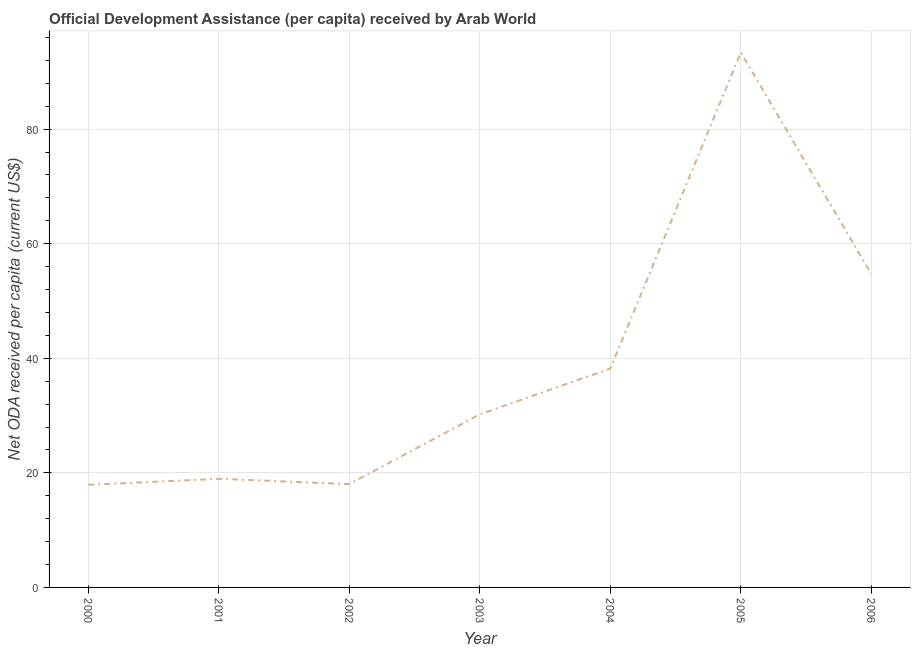What is the net oda received per capita in 2001?
Make the answer very short. 18.96. Across all years, what is the maximum net oda received per capita?
Your answer should be very brief. 93.38. Across all years, what is the minimum net oda received per capita?
Offer a very short reply. 17.91. In which year was the net oda received per capita minimum?
Offer a very short reply. 2000. What is the sum of the net oda received per capita?
Provide a succinct answer. 271.38. What is the difference between the net oda received per capita in 2000 and 2001?
Provide a succinct answer. -1.05. What is the average net oda received per capita per year?
Offer a terse response. 38.77. What is the median net oda received per capita?
Give a very brief answer. 30.21. In how many years, is the net oda received per capita greater than 52 US$?
Provide a short and direct response. 2. Do a majority of the years between 2004 and 2000 (inclusive) have net oda received per capita greater than 80 US$?
Your answer should be compact. Yes. What is the ratio of the net oda received per capita in 2002 to that in 2003?
Ensure brevity in your answer.  0.6. Is the net oda received per capita in 2005 less than that in 2006?
Your answer should be very brief. No. Is the difference between the net oda received per capita in 2001 and 2002 greater than the difference between any two years?
Your answer should be compact. No. What is the difference between the highest and the second highest net oda received per capita?
Keep it short and to the point. 38.68. What is the difference between the highest and the lowest net oda received per capita?
Provide a succinct answer. 75.47. Does the net oda received per capita monotonically increase over the years?
Keep it short and to the point. No. Are the values on the major ticks of Y-axis written in scientific E-notation?
Provide a succinct answer. No. Does the graph contain grids?
Offer a very short reply. Yes. What is the title of the graph?
Give a very brief answer. Official Development Assistance (per capita) received by Arab World. What is the label or title of the X-axis?
Make the answer very short. Year. What is the label or title of the Y-axis?
Make the answer very short. Net ODA received per capita (current US$). What is the Net ODA received per capita (current US$) in 2000?
Your answer should be very brief. 17.91. What is the Net ODA received per capita (current US$) of 2001?
Offer a terse response. 18.96. What is the Net ODA received per capita (current US$) in 2002?
Provide a succinct answer. 18.03. What is the Net ODA received per capita (current US$) of 2003?
Provide a short and direct response. 30.21. What is the Net ODA received per capita (current US$) in 2004?
Your answer should be very brief. 38.2. What is the Net ODA received per capita (current US$) in 2005?
Give a very brief answer. 93.38. What is the Net ODA received per capita (current US$) in 2006?
Your response must be concise. 54.7. What is the difference between the Net ODA received per capita (current US$) in 2000 and 2001?
Ensure brevity in your answer.  -1.05. What is the difference between the Net ODA received per capita (current US$) in 2000 and 2002?
Provide a short and direct response. -0.12. What is the difference between the Net ODA received per capita (current US$) in 2000 and 2003?
Keep it short and to the point. -12.3. What is the difference between the Net ODA received per capita (current US$) in 2000 and 2004?
Keep it short and to the point. -20.28. What is the difference between the Net ODA received per capita (current US$) in 2000 and 2005?
Your answer should be very brief. -75.47. What is the difference between the Net ODA received per capita (current US$) in 2000 and 2006?
Provide a succinct answer. -36.79. What is the difference between the Net ODA received per capita (current US$) in 2001 and 2002?
Provide a succinct answer. 0.93. What is the difference between the Net ODA received per capita (current US$) in 2001 and 2003?
Ensure brevity in your answer.  -11.25. What is the difference between the Net ODA received per capita (current US$) in 2001 and 2004?
Make the answer very short. -19.23. What is the difference between the Net ODA received per capita (current US$) in 2001 and 2005?
Give a very brief answer. -74.42. What is the difference between the Net ODA received per capita (current US$) in 2001 and 2006?
Make the answer very short. -35.74. What is the difference between the Net ODA received per capita (current US$) in 2002 and 2003?
Offer a terse response. -12.18. What is the difference between the Net ODA received per capita (current US$) in 2002 and 2004?
Your answer should be very brief. -20.17. What is the difference between the Net ODA received per capita (current US$) in 2002 and 2005?
Your answer should be very brief. -75.35. What is the difference between the Net ODA received per capita (current US$) in 2002 and 2006?
Offer a terse response. -36.67. What is the difference between the Net ODA received per capita (current US$) in 2003 and 2004?
Offer a very short reply. -7.99. What is the difference between the Net ODA received per capita (current US$) in 2003 and 2005?
Make the answer very short. -63.17. What is the difference between the Net ODA received per capita (current US$) in 2003 and 2006?
Your response must be concise. -24.49. What is the difference between the Net ODA received per capita (current US$) in 2004 and 2005?
Make the answer very short. -55.19. What is the difference between the Net ODA received per capita (current US$) in 2004 and 2006?
Your answer should be very brief. -16.5. What is the difference between the Net ODA received per capita (current US$) in 2005 and 2006?
Make the answer very short. 38.68. What is the ratio of the Net ODA received per capita (current US$) in 2000 to that in 2001?
Your answer should be very brief. 0.94. What is the ratio of the Net ODA received per capita (current US$) in 2000 to that in 2003?
Provide a short and direct response. 0.59. What is the ratio of the Net ODA received per capita (current US$) in 2000 to that in 2004?
Your response must be concise. 0.47. What is the ratio of the Net ODA received per capita (current US$) in 2000 to that in 2005?
Your answer should be compact. 0.19. What is the ratio of the Net ODA received per capita (current US$) in 2000 to that in 2006?
Keep it short and to the point. 0.33. What is the ratio of the Net ODA received per capita (current US$) in 2001 to that in 2002?
Offer a terse response. 1.05. What is the ratio of the Net ODA received per capita (current US$) in 2001 to that in 2003?
Give a very brief answer. 0.63. What is the ratio of the Net ODA received per capita (current US$) in 2001 to that in 2004?
Make the answer very short. 0.5. What is the ratio of the Net ODA received per capita (current US$) in 2001 to that in 2005?
Ensure brevity in your answer.  0.2. What is the ratio of the Net ODA received per capita (current US$) in 2001 to that in 2006?
Your response must be concise. 0.35. What is the ratio of the Net ODA received per capita (current US$) in 2002 to that in 2003?
Offer a terse response. 0.6. What is the ratio of the Net ODA received per capita (current US$) in 2002 to that in 2004?
Offer a very short reply. 0.47. What is the ratio of the Net ODA received per capita (current US$) in 2002 to that in 2005?
Your response must be concise. 0.19. What is the ratio of the Net ODA received per capita (current US$) in 2002 to that in 2006?
Your answer should be very brief. 0.33. What is the ratio of the Net ODA received per capita (current US$) in 2003 to that in 2004?
Provide a short and direct response. 0.79. What is the ratio of the Net ODA received per capita (current US$) in 2003 to that in 2005?
Offer a terse response. 0.32. What is the ratio of the Net ODA received per capita (current US$) in 2003 to that in 2006?
Make the answer very short. 0.55. What is the ratio of the Net ODA received per capita (current US$) in 2004 to that in 2005?
Your answer should be very brief. 0.41. What is the ratio of the Net ODA received per capita (current US$) in 2004 to that in 2006?
Your answer should be compact. 0.7. What is the ratio of the Net ODA received per capita (current US$) in 2005 to that in 2006?
Offer a terse response. 1.71. 